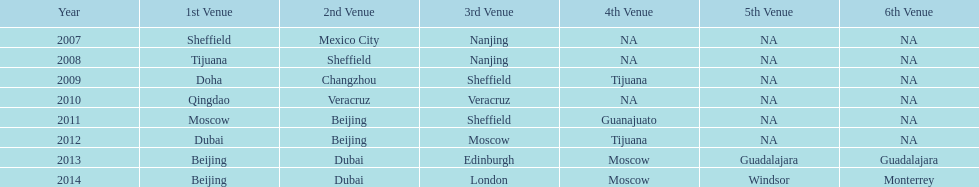In the venue hierarchy, how many years was beijing positioned over moscow? 3. 